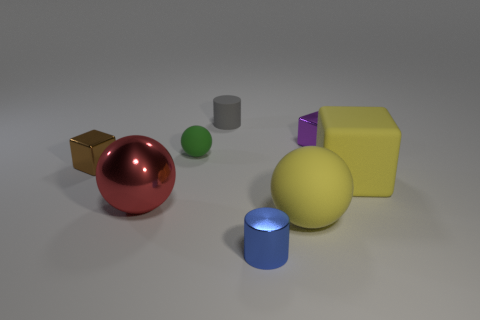Are there any other things that are the same material as the small gray thing?
Your answer should be very brief. Yes. What number of yellow spheres are in front of the small purple thing that is behind the red shiny object?
Ensure brevity in your answer.  1. There is a block that is both right of the green object and behind the yellow rubber block; what is its material?
Provide a succinct answer. Metal. Does the tiny object that is on the right side of the blue object have the same shape as the small brown shiny object?
Your answer should be very brief. Yes. Are there fewer green spheres than cyan metallic cylinders?
Provide a short and direct response. No. How many big metal things have the same color as the big rubber ball?
Keep it short and to the point. 0. What is the material of the big block that is the same color as the big matte sphere?
Make the answer very short. Rubber. Does the rubber block have the same color as the ball that is right of the small blue metallic thing?
Your response must be concise. Yes. Is the number of tiny blocks greater than the number of large metallic objects?
Provide a short and direct response. Yes. What is the size of the yellow thing that is the same shape as the tiny purple object?
Your answer should be compact. Large. 